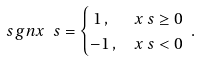<formula> <loc_0><loc_0><loc_500><loc_500>\ s g n x _ { \ } s & = \begin{cases} \, 1 \, , & x _ { \ } s \geq 0 \\ - 1 \, , & x _ { \ } s < 0 \end{cases} \, .</formula> 